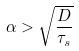Convert formula to latex. <formula><loc_0><loc_0><loc_500><loc_500>\alpha > \sqrt { \frac { D } { \tau _ { s } } }</formula> 